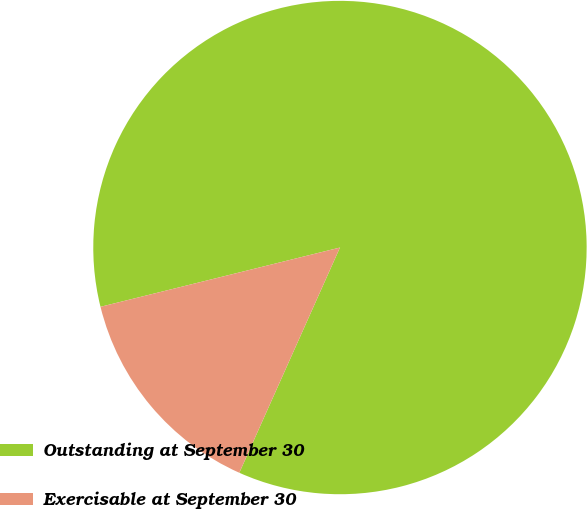Convert chart to OTSL. <chart><loc_0><loc_0><loc_500><loc_500><pie_chart><fcel>Outstanding at September 30<fcel>Exercisable at September 30<nl><fcel>85.55%<fcel>14.45%<nl></chart> 